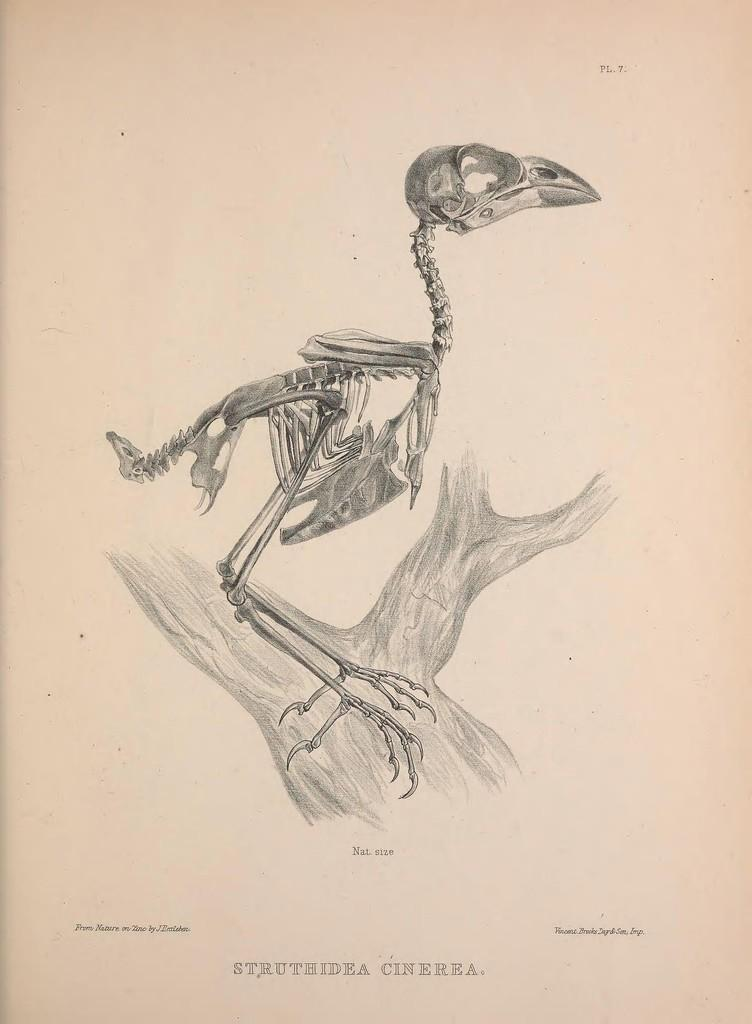What is depicted on the paper in the image? The paper contains a sketch of a skeleton and a sketch of a tree. What type of content is present on the paper besides the sketches? There is text at the bottom of the paper. What type of furniture is depicted in the sketch of the skeleton? There is no furniture depicted in the sketch of the skeleton, as it is a drawing of a human skeletal structure. 